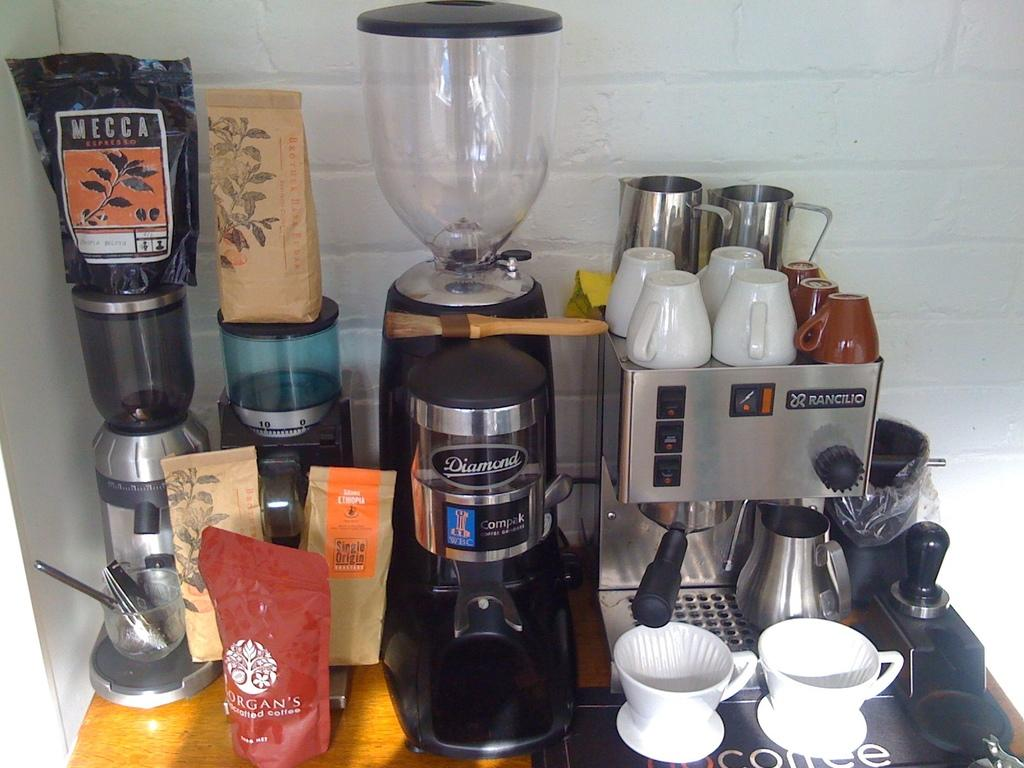What is the main piece of furniture in the image? There is a table in the image. What items related to coffee can be seen on the table? There are coffee makers and cups on the table. What else is present on the table? There are packets on the table. What can be seen in the background of the image? There is a wall in the background of the image. Can you see a lake in the background of the image? No, there is no lake present in the image; only a wall can be seen in the background. 